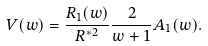Convert formula to latex. <formula><loc_0><loc_0><loc_500><loc_500>V ( w ) = \frac { R _ { 1 } ( w ) } { R ^ { * 2 } } \frac { 2 } { w + 1 } A _ { 1 } ( w ) .</formula> 